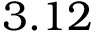<formula> <loc_0><loc_0><loc_500><loc_500>3 . 1 2</formula> 